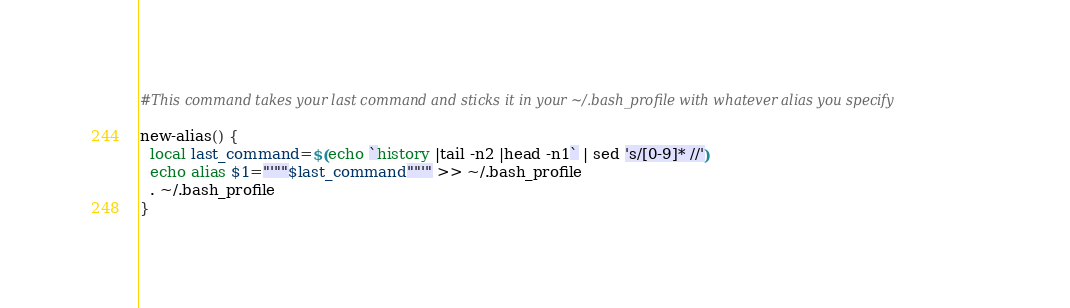<code> <loc_0><loc_0><loc_500><loc_500><_Bash_>#This command takes your last command and sticks it in your ~/.bash_profile with whatever alias you specify

new-alias() {
  local last_command=$(echo `history |tail -n2 |head -n1` | sed 's/[0-9]* //')
  echo alias $1="'""$last_command""'" >> ~/.bash_profile
  . ~/.bash_profile
}</code> 